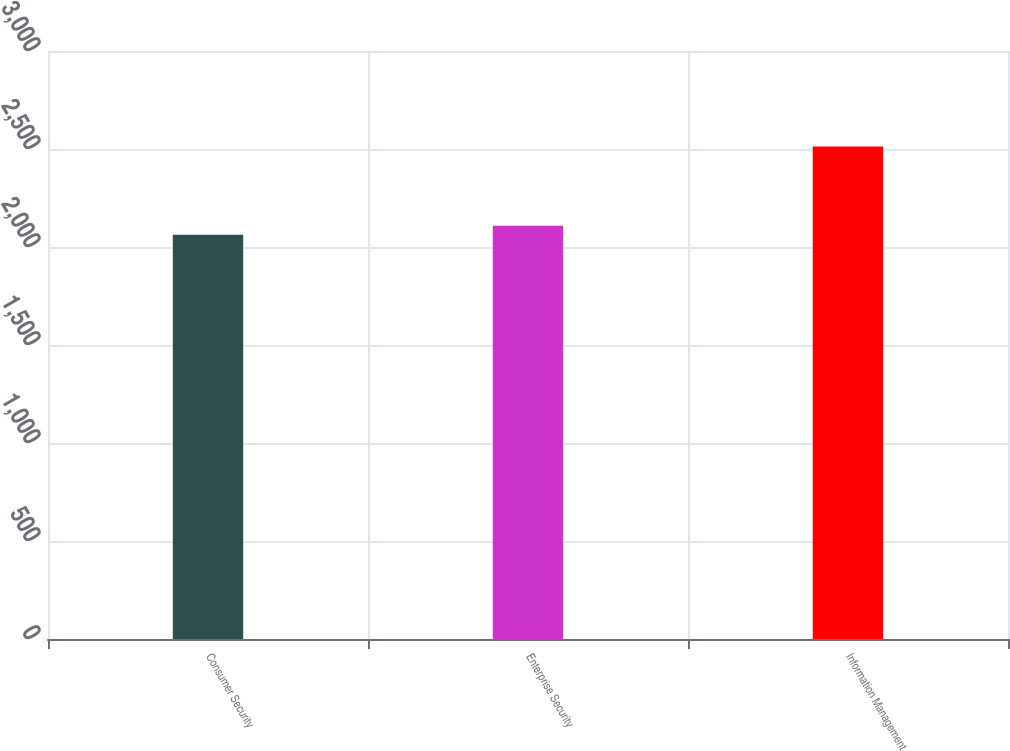<chart> <loc_0><loc_0><loc_500><loc_500><bar_chart><fcel>Consumer Security<fcel>Enterprise Security<fcel>Information Management<nl><fcel>2063<fcel>2108<fcel>2513<nl></chart> 